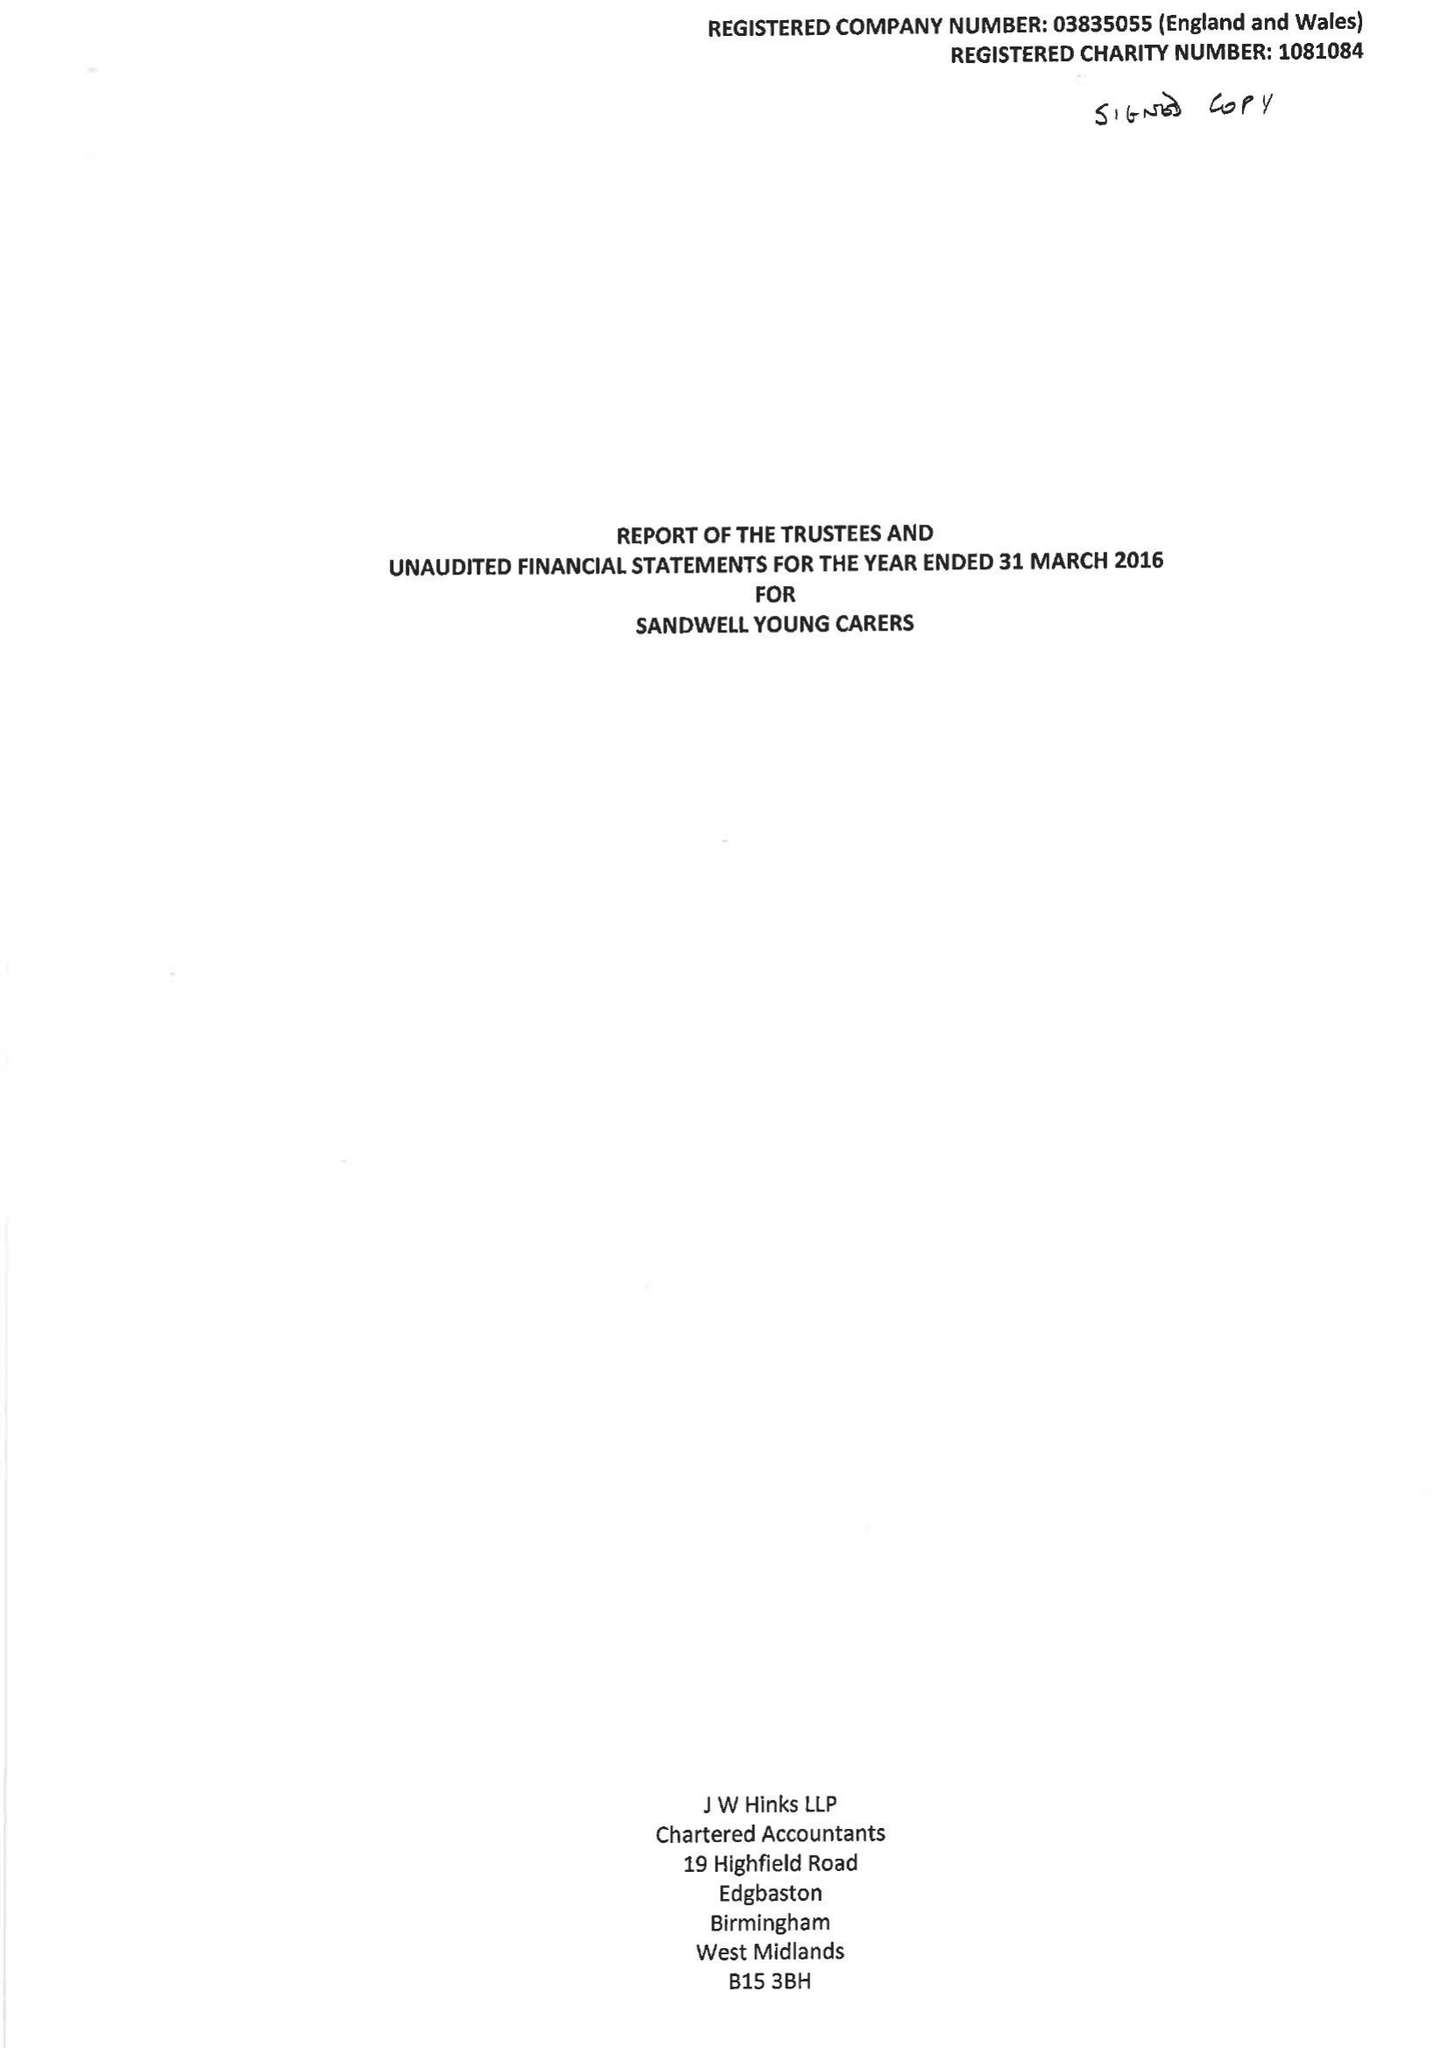What is the value for the income_annually_in_british_pounds?
Answer the question using a single word or phrase. 247949.00 